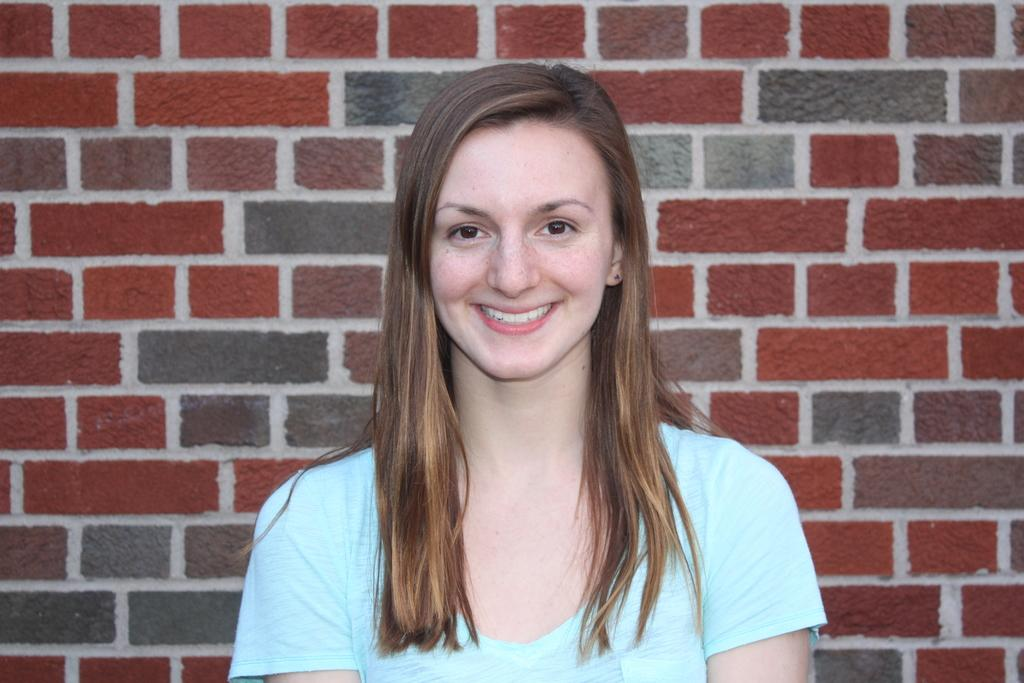What is the main subject of the image? The main subject of the image is a woman. What is the woman doing in the image? The woman is smiling in the image. What can be seen in the background of the image? There is a wall in the background of the image. What type of trouble can be seen in the image? There is no indication of trouble in the image; it features a woman who is smiling. What mass is visible in the image? There is no mass present in the image; it is a picture of a woman who is smiling. 